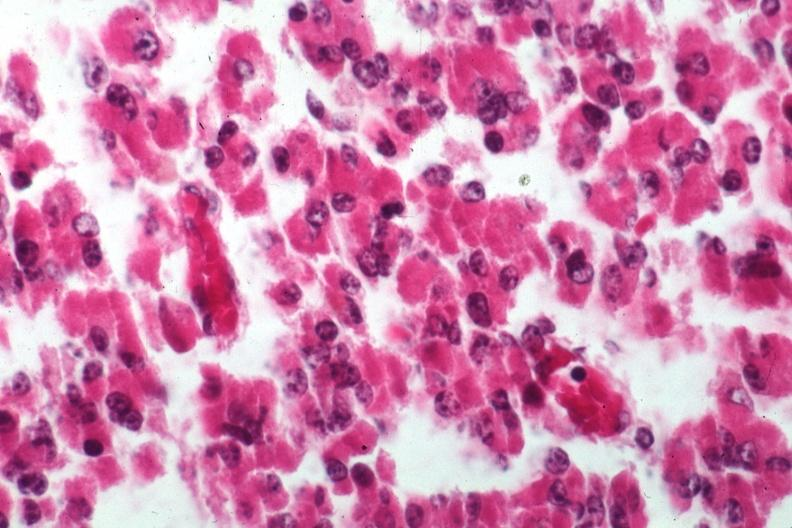s hemorrhage associated with placental abruption present?
Answer the question using a single word or phrase. No 